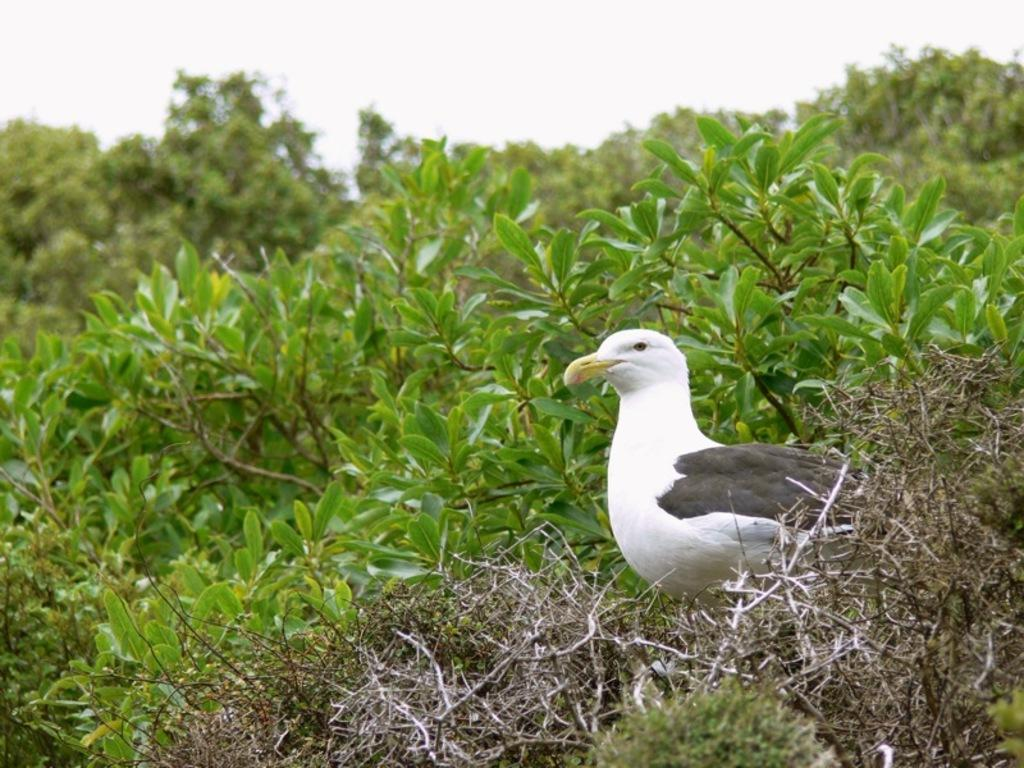What type of animal is in the image? There is a white bird in the image. Where is the bird located? The bird is on a path. What can be seen in the background of the image? There are plants, trees, and the sky visible in the background of the image. How does the bird attract the attention of the amusement park visitors in the image? There is no amusement park present in the image, and the bird is not interacting with any visitors. 